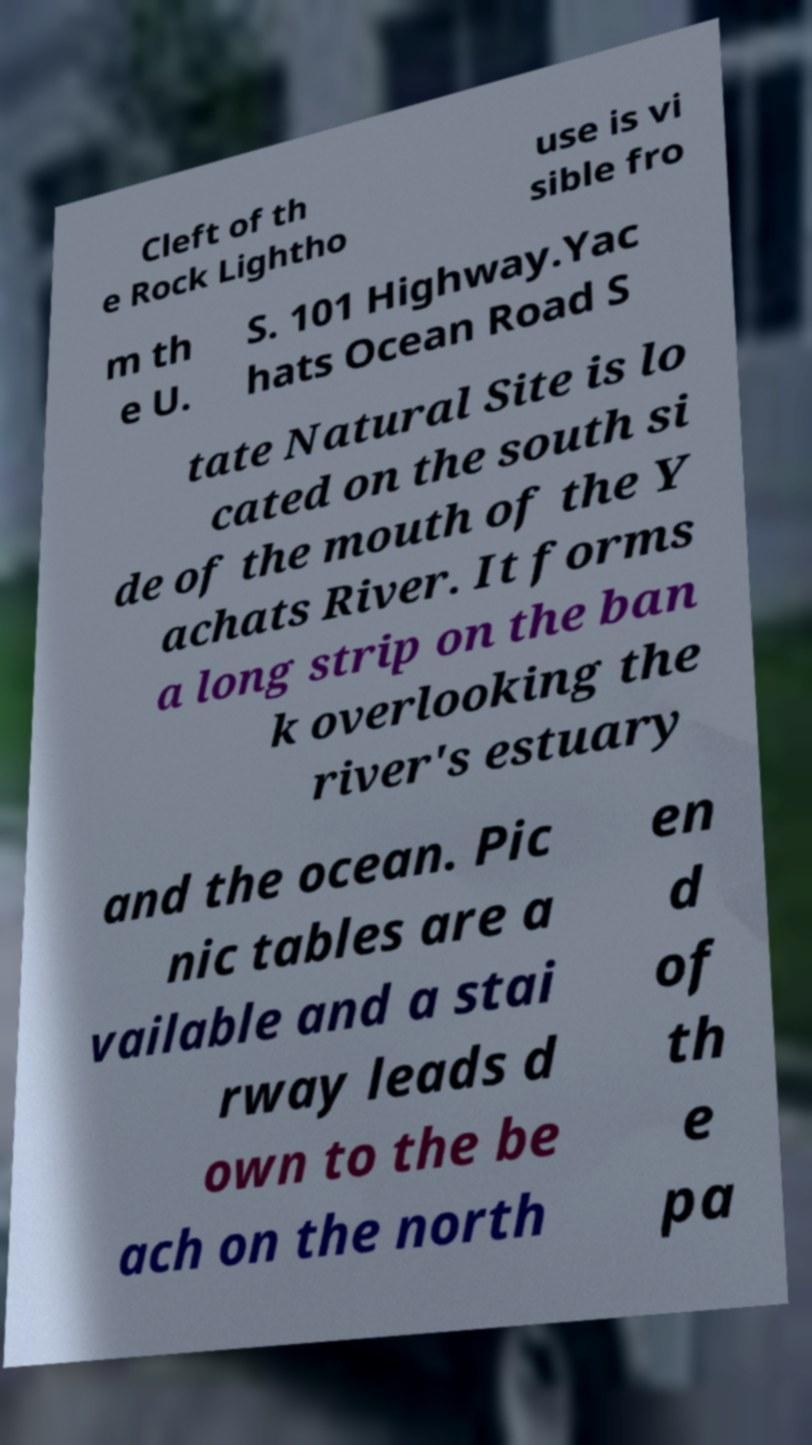Could you extract and type out the text from this image? Cleft of th e Rock Lightho use is vi sible fro m th e U. S. 101 Highway.Yac hats Ocean Road S tate Natural Site is lo cated on the south si de of the mouth of the Y achats River. It forms a long strip on the ban k overlooking the river's estuary and the ocean. Pic nic tables are a vailable and a stai rway leads d own to the be ach on the north en d of th e pa 